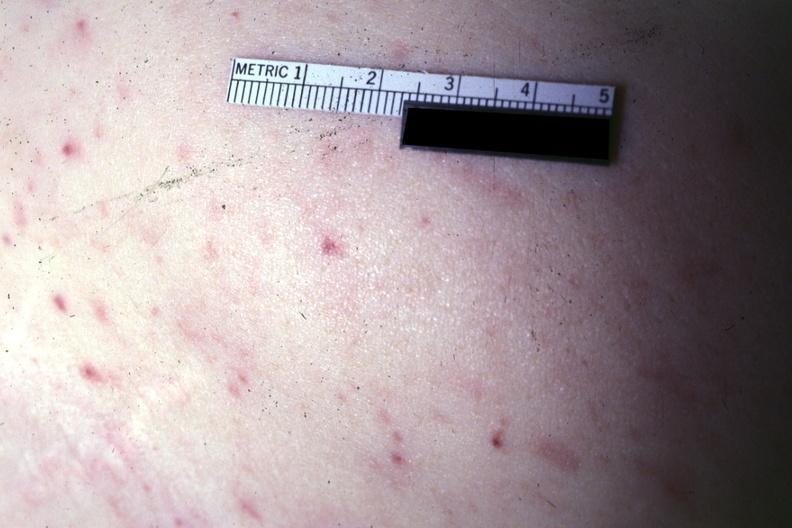does this image show lesions well shown?
Answer the question using a single word or phrase. Yes 